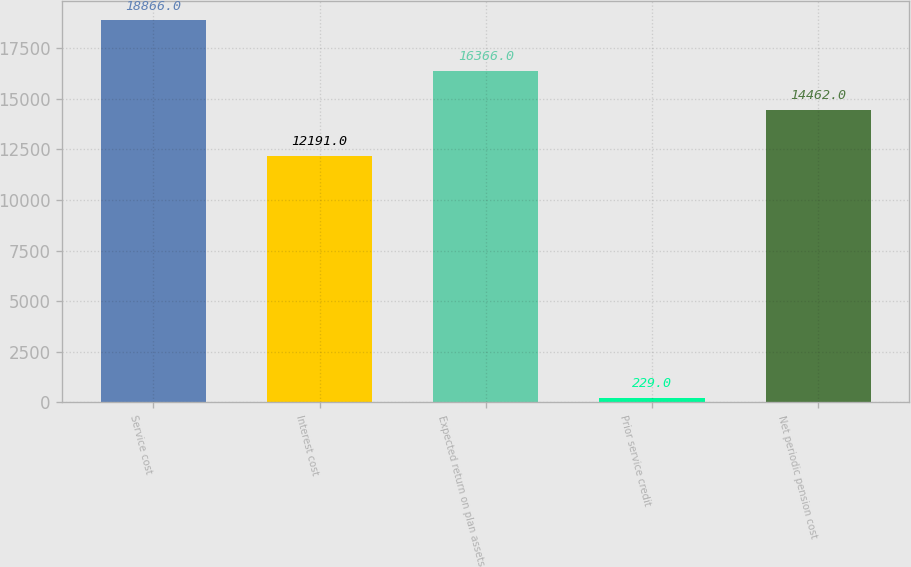Convert chart to OTSL. <chart><loc_0><loc_0><loc_500><loc_500><bar_chart><fcel>Service cost<fcel>Interest cost<fcel>Expected return on plan assets<fcel>Prior service credit<fcel>Net periodic pension cost<nl><fcel>18866<fcel>12191<fcel>16366<fcel>229<fcel>14462<nl></chart> 